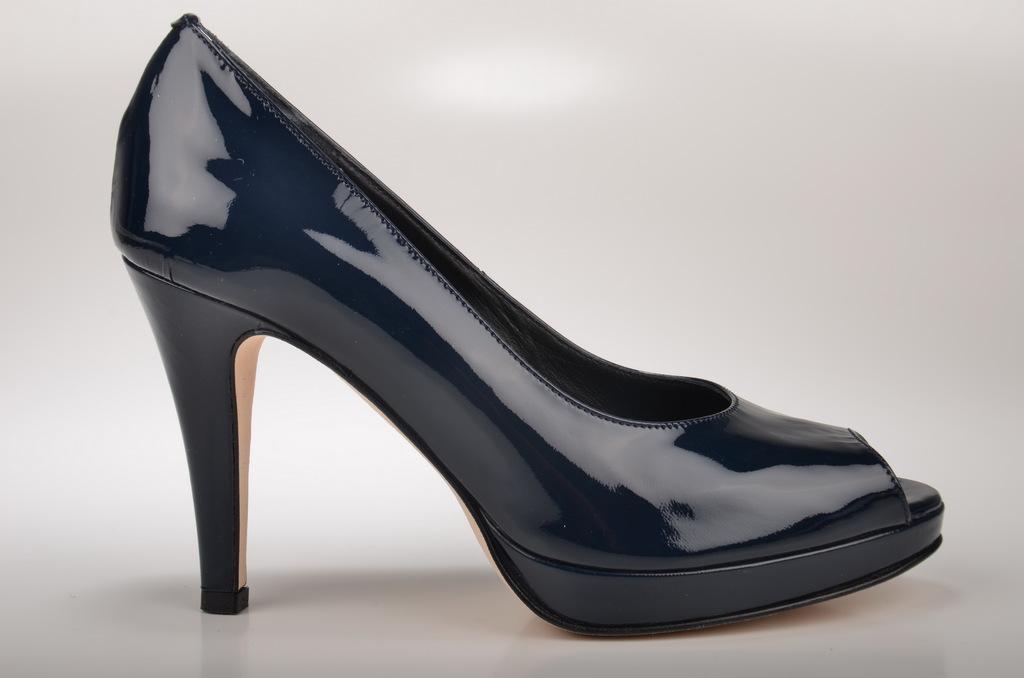Could you give a brief overview of what you see in this image? In this image we can see a high heel shoe, it is in black color, background it is in white color. 